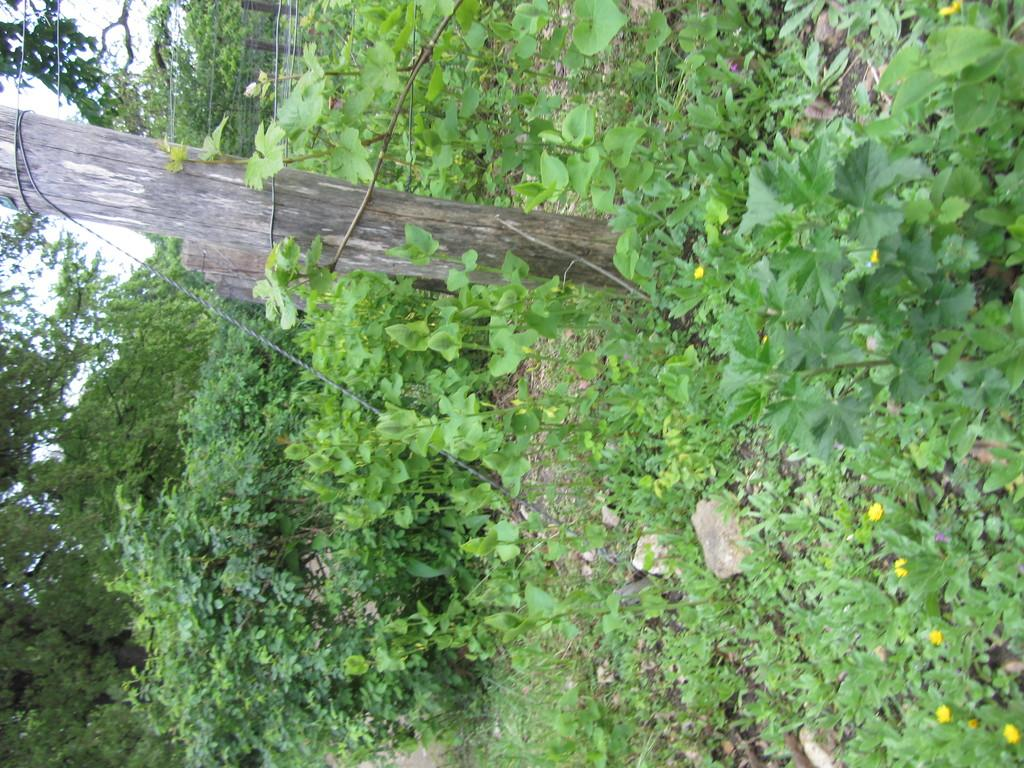How is the image oriented? The image is tilted. What type of fencing can be seen in the image? There is a wooden pole fencing in the image. What is surrounding the fencing? There are many plants around the fencing. What other natural elements are present in the image? There are trees in the image. What type of soup is being served in the image? There is no soup present in the image. Can you describe the behavior of the jellyfish in the image? There are no jellyfish present in the image. 